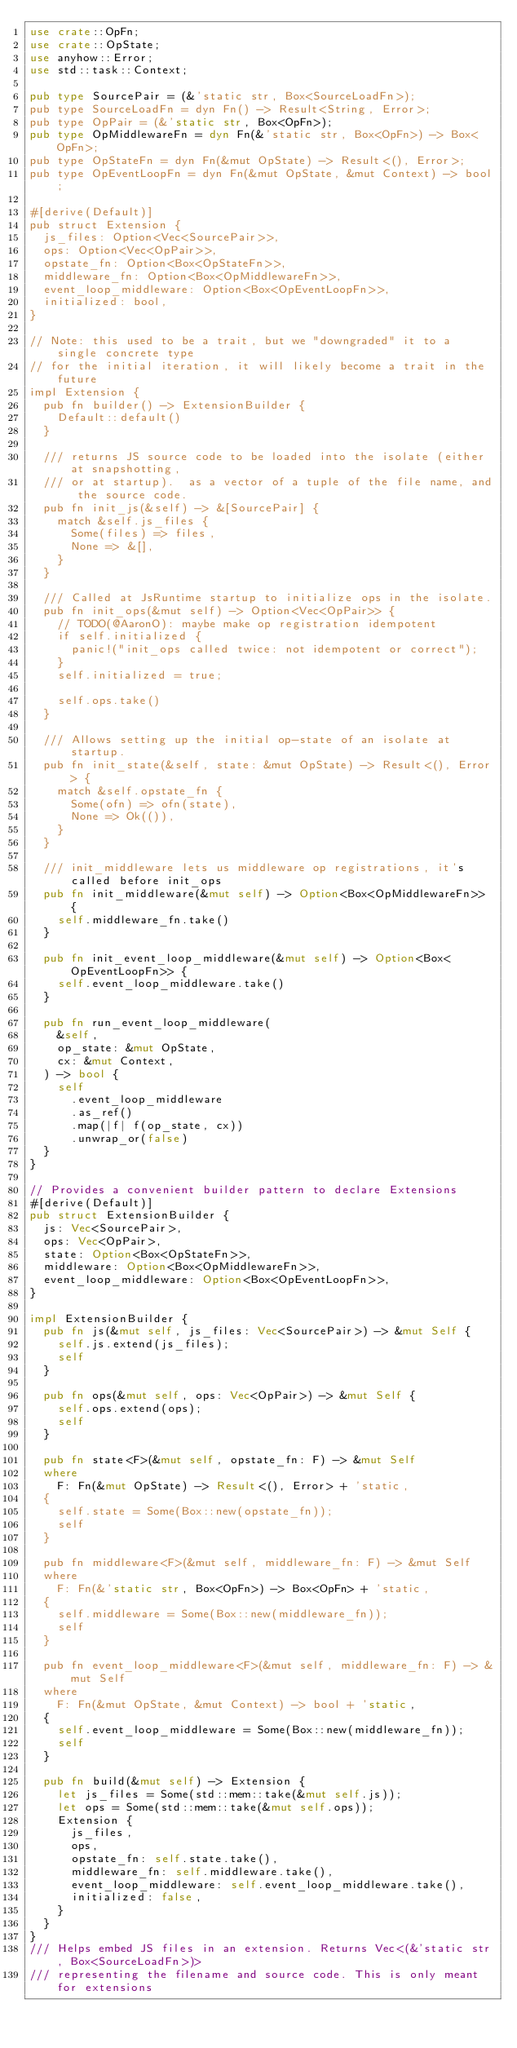Convert code to text. <code><loc_0><loc_0><loc_500><loc_500><_Rust_>use crate::OpFn;
use crate::OpState;
use anyhow::Error;
use std::task::Context;

pub type SourcePair = (&'static str, Box<SourceLoadFn>);
pub type SourceLoadFn = dyn Fn() -> Result<String, Error>;
pub type OpPair = (&'static str, Box<OpFn>);
pub type OpMiddlewareFn = dyn Fn(&'static str, Box<OpFn>) -> Box<OpFn>;
pub type OpStateFn = dyn Fn(&mut OpState) -> Result<(), Error>;
pub type OpEventLoopFn = dyn Fn(&mut OpState, &mut Context) -> bool;

#[derive(Default)]
pub struct Extension {
  js_files: Option<Vec<SourcePair>>,
  ops: Option<Vec<OpPair>>,
  opstate_fn: Option<Box<OpStateFn>>,
  middleware_fn: Option<Box<OpMiddlewareFn>>,
  event_loop_middleware: Option<Box<OpEventLoopFn>>,
  initialized: bool,
}

// Note: this used to be a trait, but we "downgraded" it to a single concrete type
// for the initial iteration, it will likely become a trait in the future
impl Extension {
  pub fn builder() -> ExtensionBuilder {
    Default::default()
  }

  /// returns JS source code to be loaded into the isolate (either at snapshotting,
  /// or at startup).  as a vector of a tuple of the file name, and the source code.
  pub fn init_js(&self) -> &[SourcePair] {
    match &self.js_files {
      Some(files) => files,
      None => &[],
    }
  }

  /// Called at JsRuntime startup to initialize ops in the isolate.
  pub fn init_ops(&mut self) -> Option<Vec<OpPair>> {
    // TODO(@AaronO): maybe make op registration idempotent
    if self.initialized {
      panic!("init_ops called twice: not idempotent or correct");
    }
    self.initialized = true;

    self.ops.take()
  }

  /// Allows setting up the initial op-state of an isolate at startup.
  pub fn init_state(&self, state: &mut OpState) -> Result<(), Error> {
    match &self.opstate_fn {
      Some(ofn) => ofn(state),
      None => Ok(()),
    }
  }

  /// init_middleware lets us middleware op registrations, it's called before init_ops
  pub fn init_middleware(&mut self) -> Option<Box<OpMiddlewareFn>> {
    self.middleware_fn.take()
  }

  pub fn init_event_loop_middleware(&mut self) -> Option<Box<OpEventLoopFn>> {
    self.event_loop_middleware.take()
  }

  pub fn run_event_loop_middleware(
    &self,
    op_state: &mut OpState,
    cx: &mut Context,
  ) -> bool {
    self
      .event_loop_middleware
      .as_ref()
      .map(|f| f(op_state, cx))
      .unwrap_or(false)
  }
}

// Provides a convenient builder pattern to declare Extensions
#[derive(Default)]
pub struct ExtensionBuilder {
  js: Vec<SourcePair>,
  ops: Vec<OpPair>,
  state: Option<Box<OpStateFn>>,
  middleware: Option<Box<OpMiddlewareFn>>,
  event_loop_middleware: Option<Box<OpEventLoopFn>>,
}

impl ExtensionBuilder {
  pub fn js(&mut self, js_files: Vec<SourcePair>) -> &mut Self {
    self.js.extend(js_files);
    self
  }

  pub fn ops(&mut self, ops: Vec<OpPair>) -> &mut Self {
    self.ops.extend(ops);
    self
  }

  pub fn state<F>(&mut self, opstate_fn: F) -> &mut Self
  where
    F: Fn(&mut OpState) -> Result<(), Error> + 'static,
  {
    self.state = Some(Box::new(opstate_fn));
    self
  }

  pub fn middleware<F>(&mut self, middleware_fn: F) -> &mut Self
  where
    F: Fn(&'static str, Box<OpFn>) -> Box<OpFn> + 'static,
  {
    self.middleware = Some(Box::new(middleware_fn));
    self
  }

  pub fn event_loop_middleware<F>(&mut self, middleware_fn: F) -> &mut Self
  where
    F: Fn(&mut OpState, &mut Context) -> bool + 'static,
  {
    self.event_loop_middleware = Some(Box::new(middleware_fn));
    self
  }

  pub fn build(&mut self) -> Extension {
    let js_files = Some(std::mem::take(&mut self.js));
    let ops = Some(std::mem::take(&mut self.ops));
    Extension {
      js_files,
      ops,
      opstate_fn: self.state.take(),
      middleware_fn: self.middleware.take(),
      event_loop_middleware: self.event_loop_middleware.take(),
      initialized: false,
    }
  }
}
/// Helps embed JS files in an extension. Returns Vec<(&'static str, Box<SourceLoadFn>)>
/// representing the filename and source code. This is only meant for extensions</code> 